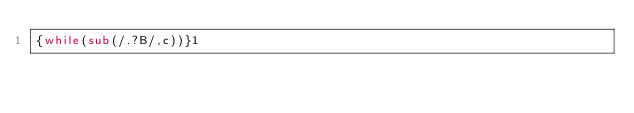Convert code to text. <code><loc_0><loc_0><loc_500><loc_500><_Awk_>{while(sub(/.?B/,c))}1</code> 